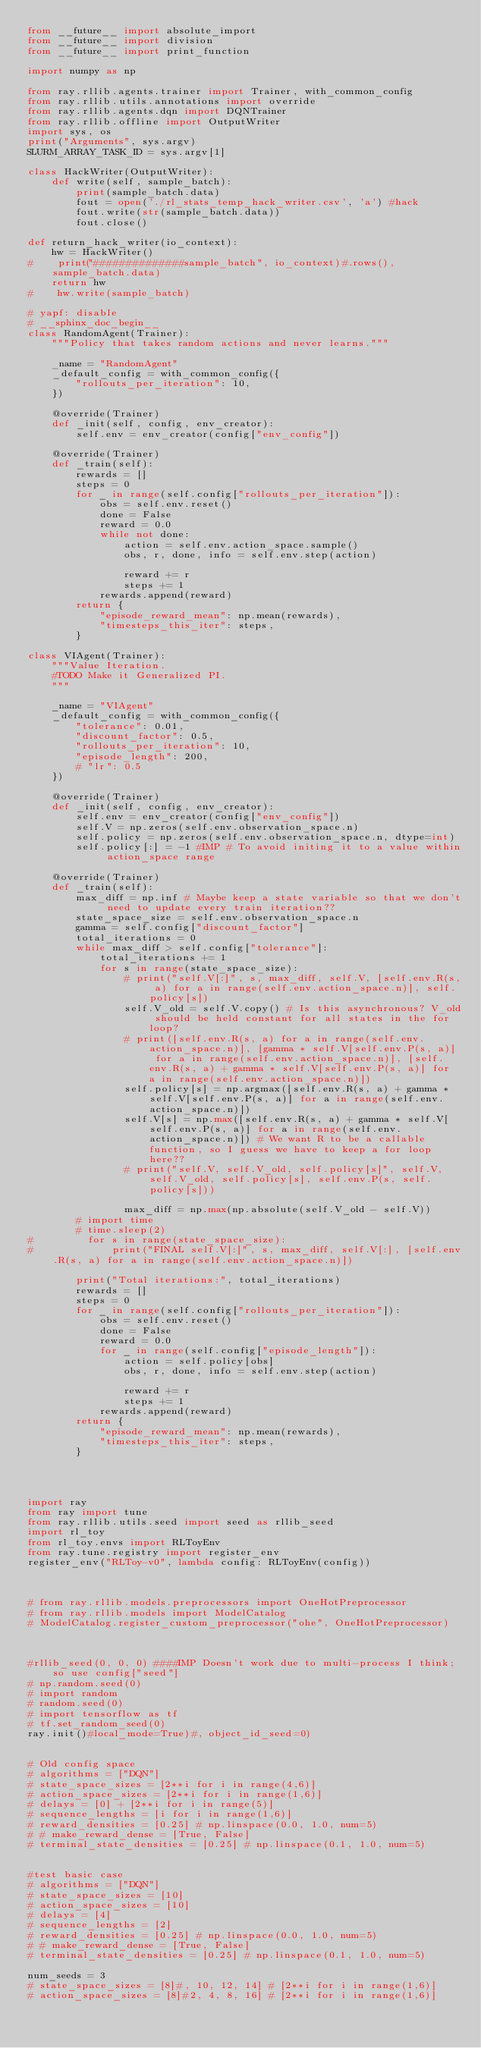<code> <loc_0><loc_0><loc_500><loc_500><_Python_>from __future__ import absolute_import
from __future__ import division
from __future__ import print_function

import numpy as np

from ray.rllib.agents.trainer import Trainer, with_common_config
from ray.rllib.utils.annotations import override
from ray.rllib.agents.dqn import DQNTrainer
from ray.rllib.offline import OutputWriter
import sys, os
print("Arguments", sys.argv)
SLURM_ARRAY_TASK_ID = sys.argv[1]

class HackWriter(OutputWriter):
    def write(self, sample_batch):
        print(sample_batch.data)
        fout = open('./rl_stats_temp_hack_writer.csv', 'a') #hack
        fout.write(str(sample_batch.data))
        fout.close()

def return_hack_writer(io_context):
    hw = HackWriter()
#    print("##############sample_batch", io_context)#.rows(), sample_batch.data)
    return hw
#    hw.write(sample_batch)

# yapf: disable
# __sphinx_doc_begin__
class RandomAgent(Trainer):
    """Policy that takes random actions and never learns."""

    _name = "RandomAgent"
    _default_config = with_common_config({
        "rollouts_per_iteration": 10,
    })

    @override(Trainer)
    def _init(self, config, env_creator):
        self.env = env_creator(config["env_config"])

    @override(Trainer)
    def _train(self):
        rewards = []
        steps = 0
        for _ in range(self.config["rollouts_per_iteration"]):
            obs = self.env.reset()
            done = False
            reward = 0.0
            while not done:
                action = self.env.action_space.sample()
                obs, r, done, info = self.env.step(action)

                reward += r
                steps += 1
            rewards.append(reward)
        return {
            "episode_reward_mean": np.mean(rewards),
            "timesteps_this_iter": steps,
        }

class VIAgent(Trainer):
    """Value Iteration.
    #TODO Make it Generalized PI.
    """

    _name = "VIAgent"
    _default_config = with_common_config({
        "tolerance": 0.01,
        "discount_factor": 0.5,
        "rollouts_per_iteration": 10,
        "episode_length": 200,
        # "lr": 0.5
    })

    @override(Trainer)
    def _init(self, config, env_creator):
        self.env = env_creator(config["env_config"])
        self.V = np.zeros(self.env.observation_space.n)
        self.policy = np.zeros(self.env.observation_space.n, dtype=int)
        self.policy[:] = -1 #IMP # To avoid initing it to a value within action_space range

    @override(Trainer)
    def _train(self):
        max_diff = np.inf # Maybe keep a state variable so that we don't need to update every train iteration??
        state_space_size = self.env.observation_space.n
        gamma = self.config["discount_factor"]
        total_iterations = 0
        while max_diff > self.config["tolerance"]:
            total_iterations += 1
            for s in range(state_space_size):
                # print("self.V[:]", s, max_diff, self.V, [self.env.R(s, a) for a in range(self.env.action_space.n)], self.policy[s])
                self.V_old = self.V.copy() # Is this asynchronous? V_old should be held constant for all states in the for loop?
                # print([self.env.R(s, a) for a in range(self.env.action_space.n)], [gamma * self.V[self.env.P(s, a)] for a in range(self.env.action_space.n)], [self.env.R(s, a) + gamma * self.V[self.env.P(s, a)] for a in range(self.env.action_space.n)])
                self.policy[s] = np.argmax([self.env.R(s, a) + gamma * self.V[self.env.P(s, a)] for a in range(self.env.action_space.n)])
                self.V[s] = np.max([self.env.R(s, a) + gamma * self.V[self.env.P(s, a)] for a in range(self.env.action_space.n)]) # We want R to be a callable function, so I guess we have to keep a for loop here??
                # print("self.V, self.V_old, self.policy[s]", self.V, self.V_old, self.policy[s], self.env.P(s, self.policy[s]))

                max_diff = np.max(np.absolute(self.V_old - self.V))
        # import time
        # time.sleep(2)
#         for s in range(state_space_size):
#             print("FINAL self.V[:]", s, max_diff, self.V[:], [self.env.R(s, a) for a in range(self.env.action_space.n)])

        print("Total iterations:", total_iterations)
        rewards = []
        steps = 0
        for _ in range(self.config["rollouts_per_iteration"]):
            obs = self.env.reset()
            done = False
            reward = 0.0
            for _ in range(self.config["episode_length"]):
                action = self.policy[obs]
                obs, r, done, info = self.env.step(action)

                reward += r
                steps += 1
            rewards.append(reward)
        return {
            "episode_reward_mean": np.mean(rewards),
            "timesteps_this_iter": steps,
        }




import ray
from ray import tune
from ray.rllib.utils.seed import seed as rllib_seed
import rl_toy
from rl_toy.envs import RLToyEnv
from ray.tune.registry import register_env
register_env("RLToy-v0", lambda config: RLToyEnv(config))



# from ray.rllib.models.preprocessors import OneHotPreprocessor
# from ray.rllib.models import ModelCatalog
# ModelCatalog.register_custom_preprocessor("ohe", OneHotPreprocessor)



#rllib_seed(0, 0, 0) ####IMP Doesn't work due to multi-process I think; so use config["seed"]
# np.random.seed(0)
# import random
# random.seed(0)
# import tensorflow as tf
# tf.set_random_seed(0)
ray.init()#local_mode=True)#, object_id_seed=0)


# Old config space
# algorithms = ["DQN"]
# state_space_sizes = [2**i for i in range(4,6)]
# action_space_sizes = [2**i for i in range(1,6)]
# delays = [0] + [2**i for i in range(5)]
# sequence_lengths = [i for i in range(1,6)]
# reward_densities = [0.25] # np.linspace(0.0, 1.0, num=5)
# # make_reward_dense = [True, False]
# terminal_state_densities = [0.25] # np.linspace(0.1, 1.0, num=5)


#test basic case
# algorithms = ["DQN"]
# state_space_sizes = [10]
# action_space_sizes = [10]
# delays = [4]
# sequence_lengths = [2]
# reward_densities = [0.25] # np.linspace(0.0, 1.0, num=5)
# # make_reward_dense = [True, False]
# terminal_state_densities = [0.25] # np.linspace(0.1, 1.0, num=5)

num_seeds = 3
# state_space_sizes = [8]#, 10, 12, 14] # [2**i for i in range(1,6)]
# action_space_sizes = [8]#2, 4, 8, 16] # [2**i for i in range(1,6)]</code> 